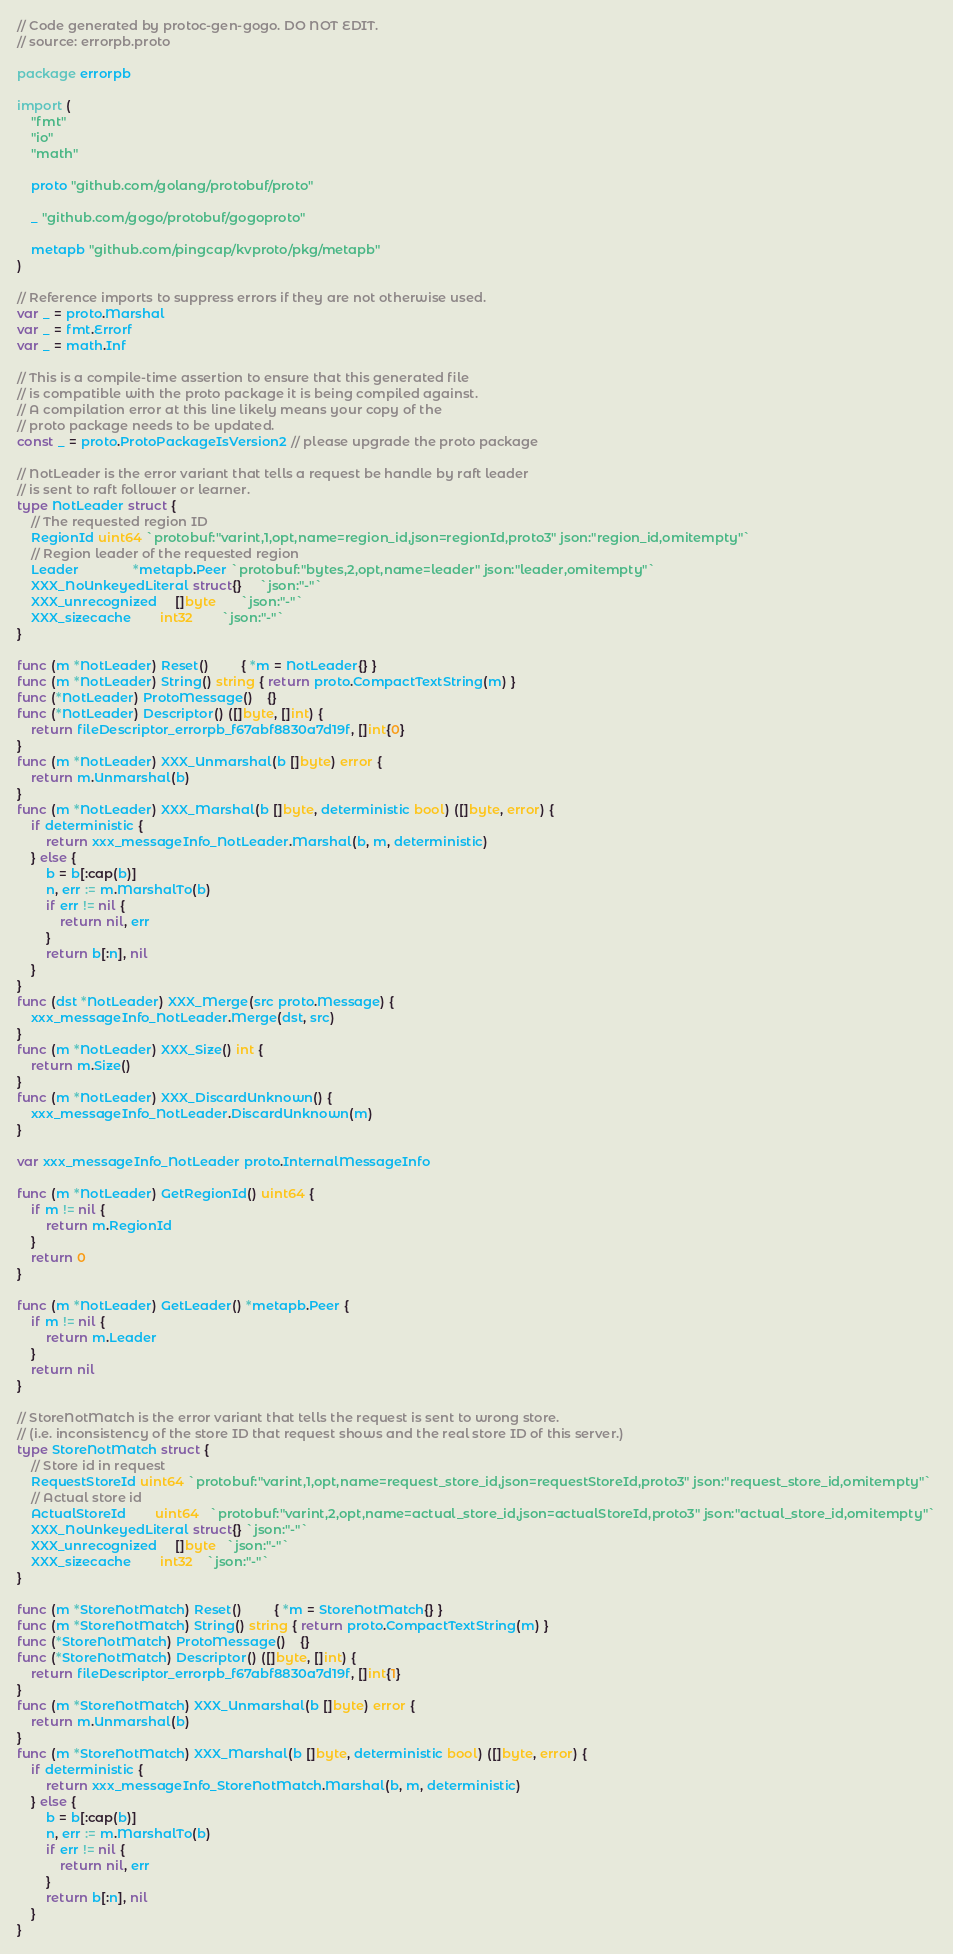<code> <loc_0><loc_0><loc_500><loc_500><_Go_>// Code generated by protoc-gen-gogo. DO NOT EDIT.
// source: errorpb.proto

package errorpb

import (
	"fmt"
	"io"
	"math"

	proto "github.com/golang/protobuf/proto"

	_ "github.com/gogo/protobuf/gogoproto"

	metapb "github.com/pingcap/kvproto/pkg/metapb"
)

// Reference imports to suppress errors if they are not otherwise used.
var _ = proto.Marshal
var _ = fmt.Errorf
var _ = math.Inf

// This is a compile-time assertion to ensure that this generated file
// is compatible with the proto package it is being compiled against.
// A compilation error at this line likely means your copy of the
// proto package needs to be updated.
const _ = proto.ProtoPackageIsVersion2 // please upgrade the proto package

// NotLeader is the error variant that tells a request be handle by raft leader
// is sent to raft follower or learner.
type NotLeader struct {
	// The requested region ID
	RegionId uint64 `protobuf:"varint,1,opt,name=region_id,json=regionId,proto3" json:"region_id,omitempty"`
	// Region leader of the requested region
	Leader               *metapb.Peer `protobuf:"bytes,2,opt,name=leader" json:"leader,omitempty"`
	XXX_NoUnkeyedLiteral struct{}     `json:"-"`
	XXX_unrecognized     []byte       `json:"-"`
	XXX_sizecache        int32        `json:"-"`
}

func (m *NotLeader) Reset()         { *m = NotLeader{} }
func (m *NotLeader) String() string { return proto.CompactTextString(m) }
func (*NotLeader) ProtoMessage()    {}
func (*NotLeader) Descriptor() ([]byte, []int) {
	return fileDescriptor_errorpb_f67abf8830a7d19f, []int{0}
}
func (m *NotLeader) XXX_Unmarshal(b []byte) error {
	return m.Unmarshal(b)
}
func (m *NotLeader) XXX_Marshal(b []byte, deterministic bool) ([]byte, error) {
	if deterministic {
		return xxx_messageInfo_NotLeader.Marshal(b, m, deterministic)
	} else {
		b = b[:cap(b)]
		n, err := m.MarshalTo(b)
		if err != nil {
			return nil, err
		}
		return b[:n], nil
	}
}
func (dst *NotLeader) XXX_Merge(src proto.Message) {
	xxx_messageInfo_NotLeader.Merge(dst, src)
}
func (m *NotLeader) XXX_Size() int {
	return m.Size()
}
func (m *NotLeader) XXX_DiscardUnknown() {
	xxx_messageInfo_NotLeader.DiscardUnknown(m)
}

var xxx_messageInfo_NotLeader proto.InternalMessageInfo

func (m *NotLeader) GetRegionId() uint64 {
	if m != nil {
		return m.RegionId
	}
	return 0
}

func (m *NotLeader) GetLeader() *metapb.Peer {
	if m != nil {
		return m.Leader
	}
	return nil
}

// StoreNotMatch is the error variant that tells the request is sent to wrong store.
// (i.e. inconsistency of the store ID that request shows and the real store ID of this server.)
type StoreNotMatch struct {
	// Store id in request
	RequestStoreId uint64 `protobuf:"varint,1,opt,name=request_store_id,json=requestStoreId,proto3" json:"request_store_id,omitempty"`
	// Actual store id
	ActualStoreId        uint64   `protobuf:"varint,2,opt,name=actual_store_id,json=actualStoreId,proto3" json:"actual_store_id,omitempty"`
	XXX_NoUnkeyedLiteral struct{} `json:"-"`
	XXX_unrecognized     []byte   `json:"-"`
	XXX_sizecache        int32    `json:"-"`
}

func (m *StoreNotMatch) Reset()         { *m = StoreNotMatch{} }
func (m *StoreNotMatch) String() string { return proto.CompactTextString(m) }
func (*StoreNotMatch) ProtoMessage()    {}
func (*StoreNotMatch) Descriptor() ([]byte, []int) {
	return fileDescriptor_errorpb_f67abf8830a7d19f, []int{1}
}
func (m *StoreNotMatch) XXX_Unmarshal(b []byte) error {
	return m.Unmarshal(b)
}
func (m *StoreNotMatch) XXX_Marshal(b []byte, deterministic bool) ([]byte, error) {
	if deterministic {
		return xxx_messageInfo_StoreNotMatch.Marshal(b, m, deterministic)
	} else {
		b = b[:cap(b)]
		n, err := m.MarshalTo(b)
		if err != nil {
			return nil, err
		}
		return b[:n], nil
	}
}</code> 